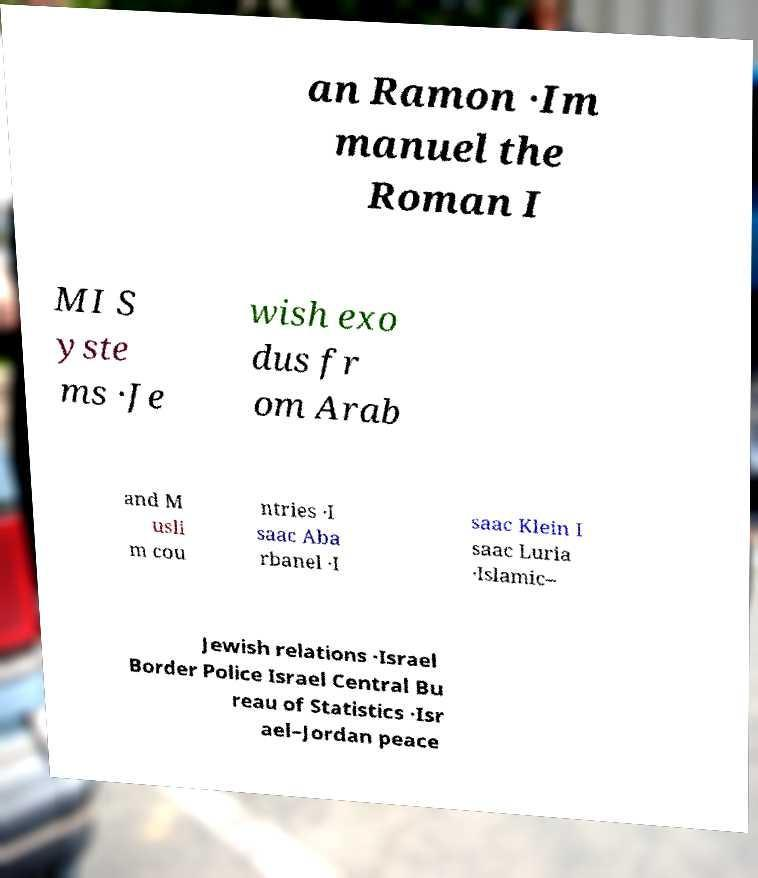Please read and relay the text visible in this image. What does it say? an Ramon ·Im manuel the Roman I MI S yste ms ·Je wish exo dus fr om Arab and M usli m cou ntries ·I saac Aba rbanel ·I saac Klein I saac Luria ·Islamic– Jewish relations ·Israel Border Police Israel Central Bu reau of Statistics ·Isr ael–Jordan peace 